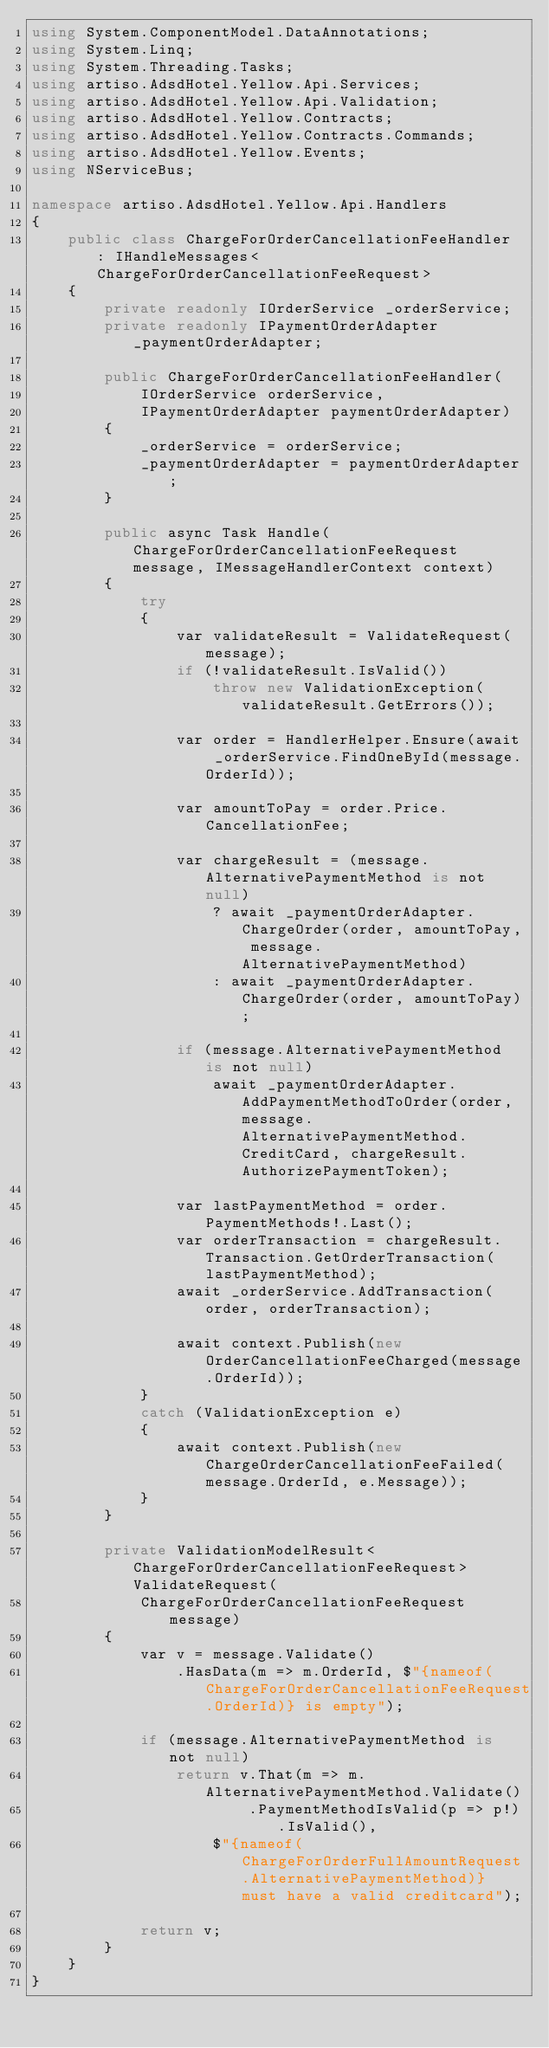<code> <loc_0><loc_0><loc_500><loc_500><_C#_>using System.ComponentModel.DataAnnotations;
using System.Linq;
using System.Threading.Tasks;
using artiso.AdsdHotel.Yellow.Api.Services;
using artiso.AdsdHotel.Yellow.Api.Validation;
using artiso.AdsdHotel.Yellow.Contracts;
using artiso.AdsdHotel.Yellow.Contracts.Commands;
using artiso.AdsdHotel.Yellow.Events;
using NServiceBus;

namespace artiso.AdsdHotel.Yellow.Api.Handlers
{
    public class ChargeForOrderCancellationFeeHandler : IHandleMessages<ChargeForOrderCancellationFeeRequest>
    {
        private readonly IOrderService _orderService;
        private readonly IPaymentOrderAdapter _paymentOrderAdapter;

        public ChargeForOrderCancellationFeeHandler(
            IOrderService orderService,
            IPaymentOrderAdapter paymentOrderAdapter)
        {
            _orderService = orderService;
            _paymentOrderAdapter = paymentOrderAdapter;
        }

        public async Task Handle(ChargeForOrderCancellationFeeRequest message, IMessageHandlerContext context)
        {
            try
            {
                var validateResult = ValidateRequest(message);
                if (!validateResult.IsValid())
                    throw new ValidationException(validateResult.GetErrors());

                var order = HandlerHelper.Ensure(await _orderService.FindOneById(message.OrderId));

                var amountToPay = order.Price.CancellationFee;

                var chargeResult = (message.AlternativePaymentMethod is not null)
                    ? await _paymentOrderAdapter.ChargeOrder(order, amountToPay, message.AlternativePaymentMethod)
                    : await _paymentOrderAdapter.ChargeOrder(order, amountToPay);

                if (message.AlternativePaymentMethod is not null)
                    await _paymentOrderAdapter.AddPaymentMethodToOrder(order, message.AlternativePaymentMethod.CreditCard, chargeResult.AuthorizePaymentToken);

                var lastPaymentMethod = order.PaymentMethods!.Last();
                var orderTransaction = chargeResult.Transaction.GetOrderTransaction(lastPaymentMethod);
                await _orderService.AddTransaction(order, orderTransaction);

                await context.Publish(new OrderCancellationFeeCharged(message.OrderId));
            }
            catch (ValidationException e)
            {
                await context.Publish(new ChargeOrderCancellationFeeFailed(message.OrderId, e.Message));
            }
        }

        private ValidationModelResult<ChargeForOrderCancellationFeeRequest> ValidateRequest(
            ChargeForOrderCancellationFeeRequest message)
        {
            var v = message.Validate()
                .HasData(m => m.OrderId, $"{nameof(ChargeForOrderCancellationFeeRequest.OrderId)} is empty");

            if (message.AlternativePaymentMethod is not null)
                return v.That(m => m.AlternativePaymentMethod.Validate()
                        .PaymentMethodIsValid(p => p!).IsValid(),
                    $"{nameof(ChargeForOrderFullAmountRequest.AlternativePaymentMethod)} must have a valid creditcard");

            return v;
        }
    }
}
</code> 